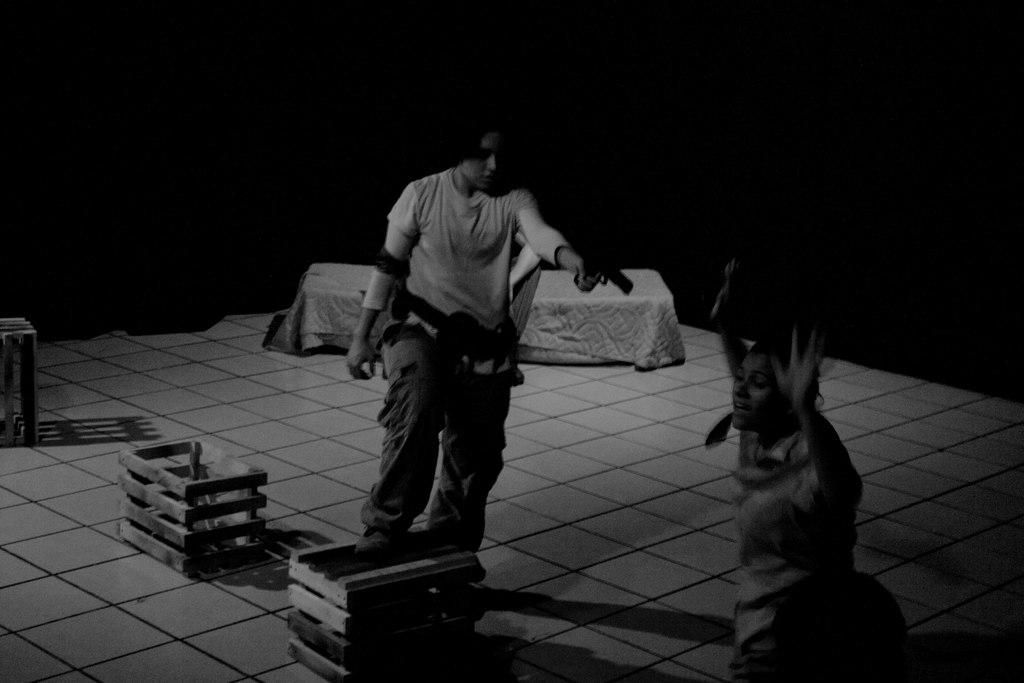How many people are in the image? There are two people in the image. What is one person holding in the image? One person is holding a gun. What can be seen in the background of the image? There is a bed and wooden boxes on the floor in the background. What is the color scheme of the image? The image is in black and white. How many boys are playing with the plough in the image? There is no plough or boys present in the image. 